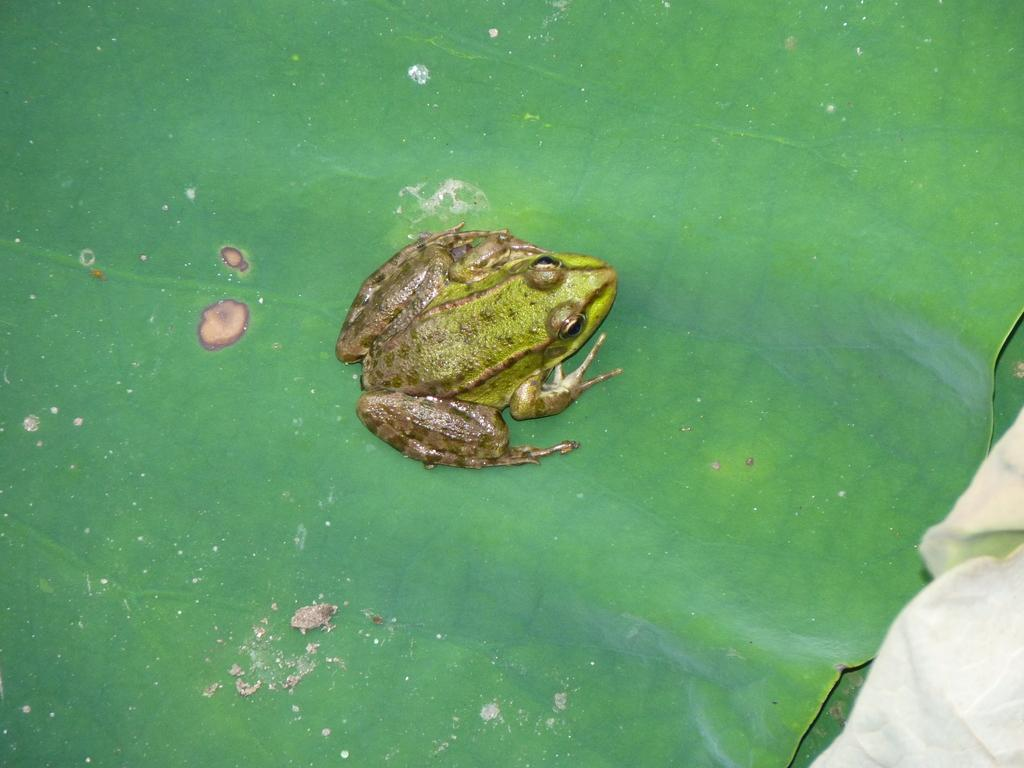What is the main subject in the center of the image? There is a frog in the center of the image. What is the frog sitting on? The frog is on a leaf. Where can the cloth be found in the image? The cloth is in the bottom right side of the image. What sound does the frog make in the image? The image is static, and there is no sound associated with it. Therefore, we cannot determine the sound the frog makes in the image. 